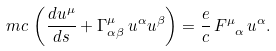Convert formula to latex. <formula><loc_0><loc_0><loc_500><loc_500>m c \, \left ( \frac { d u ^ { \mu } } { d s } + \Gamma ^ { \mu } _ { \alpha \beta } \, u ^ { \alpha } u ^ { \beta } \right ) = \frac { e } { c } \, F ^ { \mu } _ { \ \alpha } \, u ^ { \alpha } .</formula> 